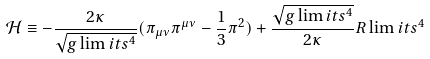<formula> <loc_0><loc_0><loc_500><loc_500>\mathcal { H } \equiv - \frac { 2 \kappa } { \sqrt { g \lim i t s ^ { 4 } } } ( \pi _ { \mu \nu } \pi ^ { \mu \nu } - \frac { 1 } { 3 } \pi ^ { 2 } ) + \frac { \sqrt { g \lim i t s ^ { 4 } } } { 2 \kappa } R \lim i t s ^ { 4 }</formula> 